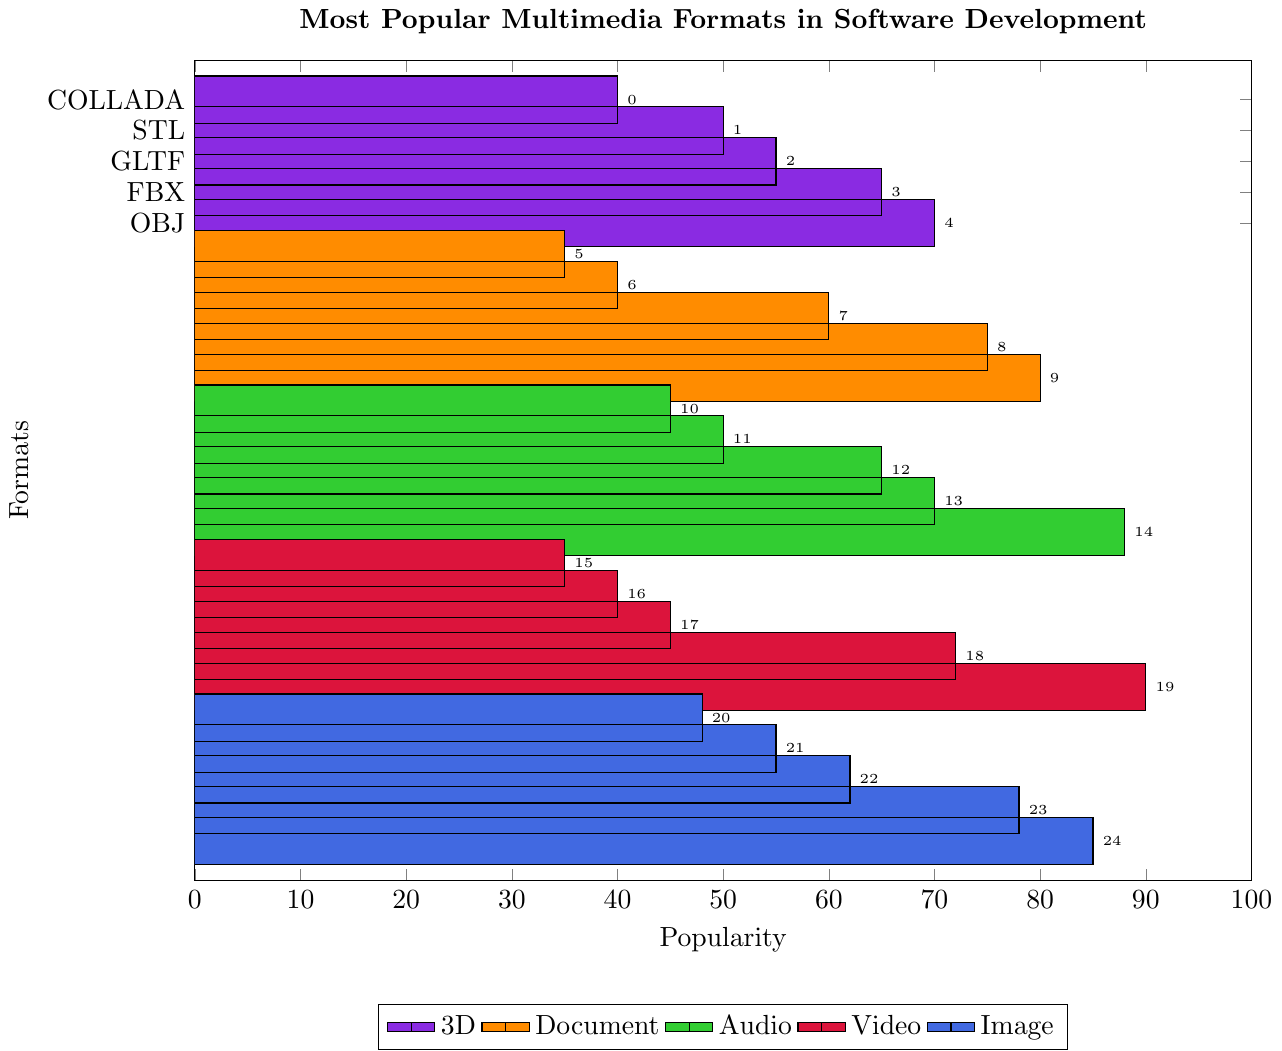Which multimedia format has the highest popularity? To find the most popular multimedia format, look for the bar reaching the highest point on the popularity axis. According to the chart, MP4 under the Video category has a popularity of 90.
Answer: MP4 Which document format is the most popular? Examine the bars associated with document formats (PDF, DOCX, TXT, RTF, EPUB) and identify the one with the highest popularity. PDF has the highest popularity at 80.
Answer: PDF What is the average popularity of the image formats? Add up the popularity values of all image formats and divide by the number of image formats. The values are 85, 78, 62, 55, and 48. Sum = 328. There are 5 formats, hence the average = 328 / 5 = 65.6.
Answer: 65.6 Compare the popularity of MP3 and MP4 formats. Which one is more popular and by how much? Check the popularity values of MP3 (Audio format) and MP4 (Video format), which are 88 and 90, respectively. MP4 is more popular by a difference of 90 - 88 = 2.
Answer: MP4 by 2 Which category has the least popular format and what is it? Identify the least popular format across all categories by looking for the smallest bar. COLLADA (3D format) is the least popular with a value of 40.
Answer: 3D, COLLADA Is PNG more popular than WebM? Compare the popularity values of PNG (Image format) and WebM (Video format). PNG has a value of 78 while WebM has 72.
Answer: Yes Which has a higher popularity: FLAC or GIF? Compare the popularity values of FLAC (Audio format, value 45) and GIF (Image format, value 55). GIF has a higher popularity.
Answer: GIF List all 3D formats and their popularity in descending order. Check the popularity of 3D formats and sort them: OBJ (70), FBX (65), GLTF (55), STL (50), COLLADA (40).
Answer: OBJ, FBX, GLTF, STL, COLLADA How much more popular is PDF compared to SVG? Subtract the popularity of SVG (Image format, value 48) from PDF (Document format, value 80). The difference is 80 - 48 = 32.
Answer: 32 What is the median popularity value of the audio formats? List the popularity values of audio formats (45, 50, 65, 70, 88) in ascending order. The median (middle value) is 65.
Answer: 65 